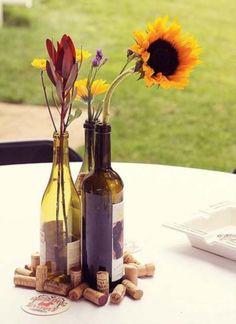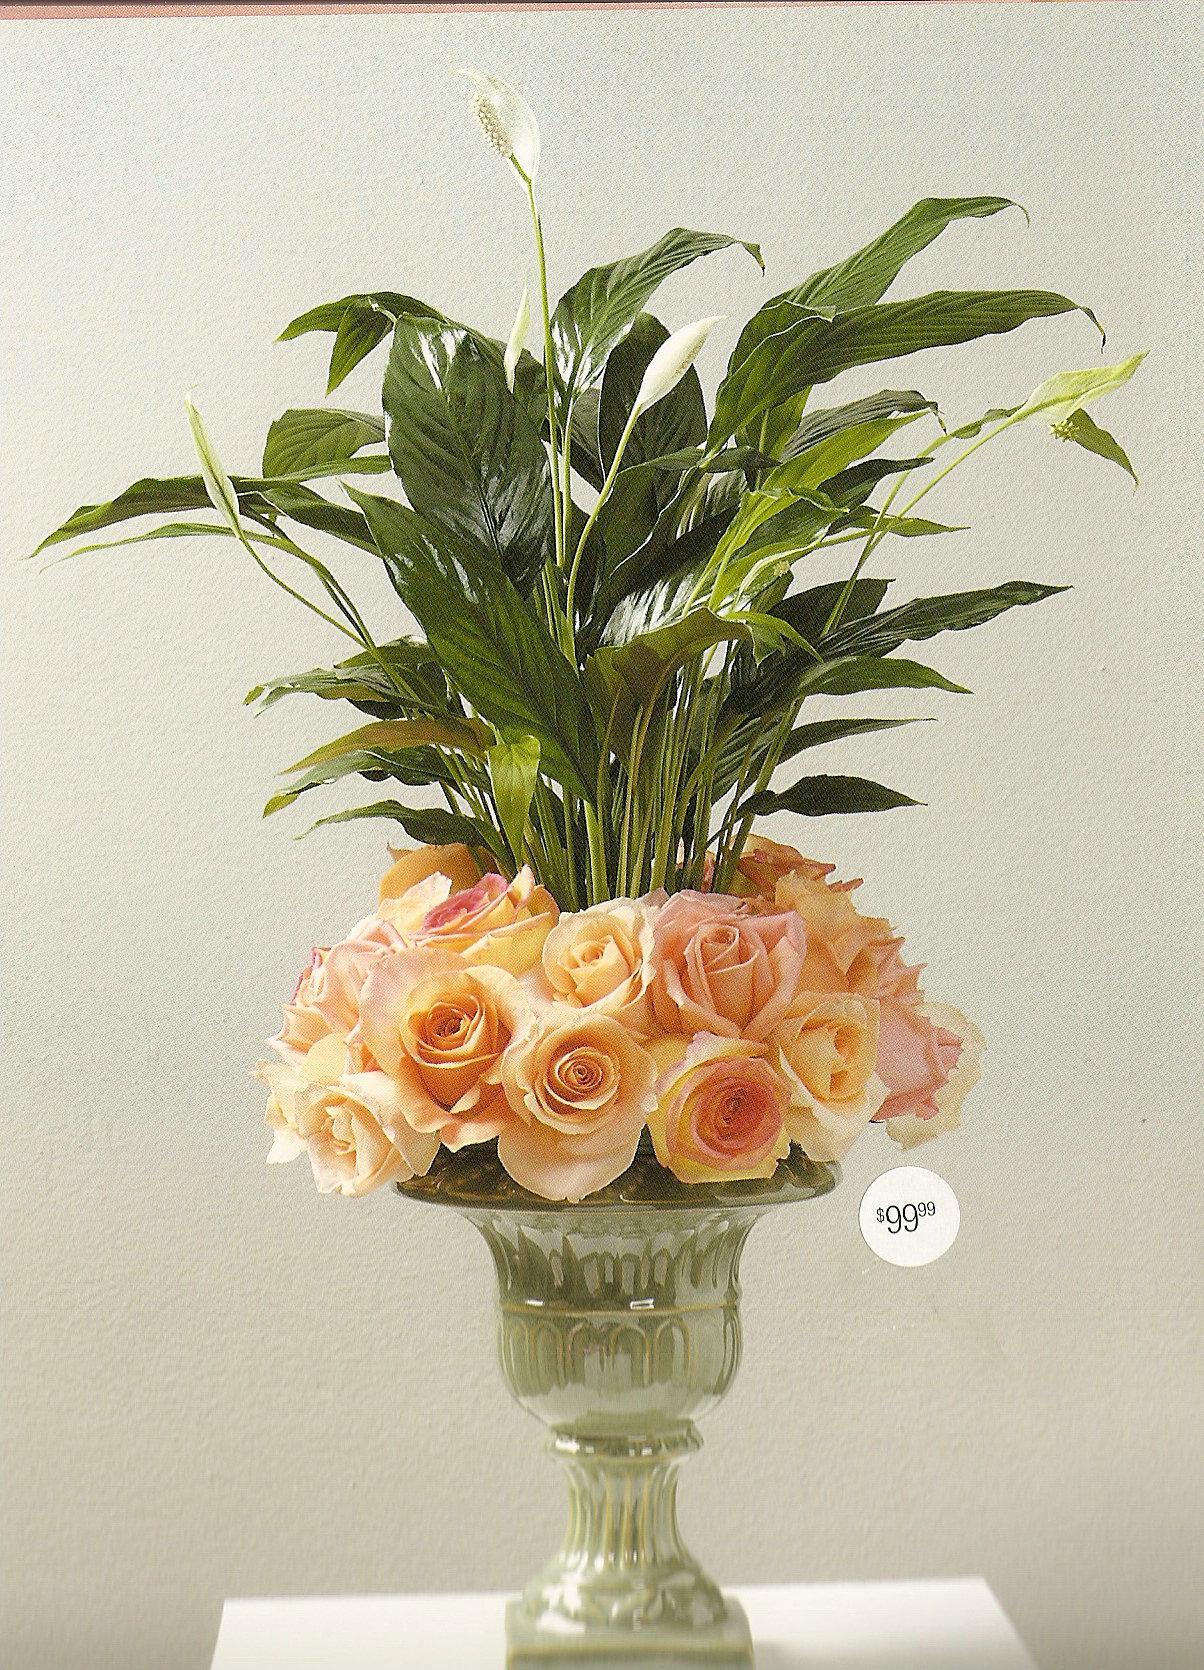The first image is the image on the left, the second image is the image on the right. Considering the images on both sides, is "An image shows a pair of vases designed with a curl shape at the bottom." valid? Answer yes or no. No. The first image is the image on the left, the second image is the image on the right. Given the left and right images, does the statement "There is at least two vases in the right image." hold true? Answer yes or no. No. 